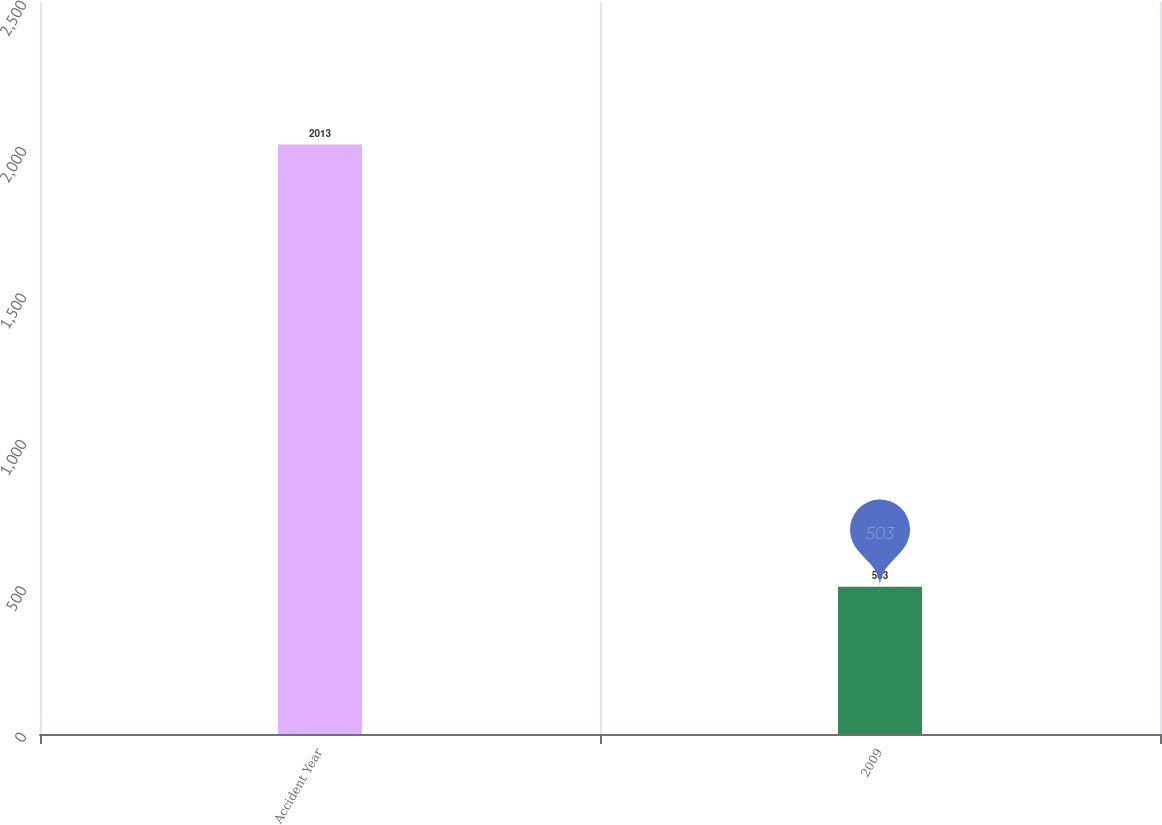Convert chart. <chart><loc_0><loc_0><loc_500><loc_500><bar_chart><fcel>Accident Year<fcel>2009<nl><fcel>2013<fcel>503<nl></chart> 